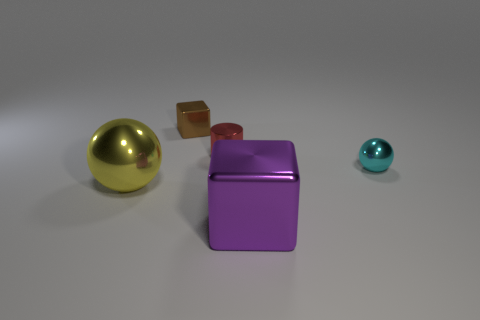How many blocks are purple metallic objects or small brown things?
Offer a terse response. 2. There is a object to the left of the tiny brown block; are there any tiny brown shiny objects in front of it?
Offer a very short reply. No. Do the cyan object and the tiny thing left of the small red shiny thing have the same shape?
Your answer should be very brief. No. What number of other things are the same size as the brown metallic block?
Your answer should be compact. 2. What number of yellow things are either big metallic balls or metallic blocks?
Your answer should be very brief. 1. What number of metal objects are behind the purple block and right of the metallic cylinder?
Your response must be concise. 1. What is the small ball that is in front of the block behind the cyan shiny sphere to the right of the brown metal cube made of?
Ensure brevity in your answer.  Metal. What number of tiny red spheres have the same material as the yellow sphere?
Offer a very short reply. 0. There is a purple object that is the same size as the yellow shiny object; what shape is it?
Your response must be concise. Cube. There is a large metallic block; are there any large spheres left of it?
Make the answer very short. Yes. 